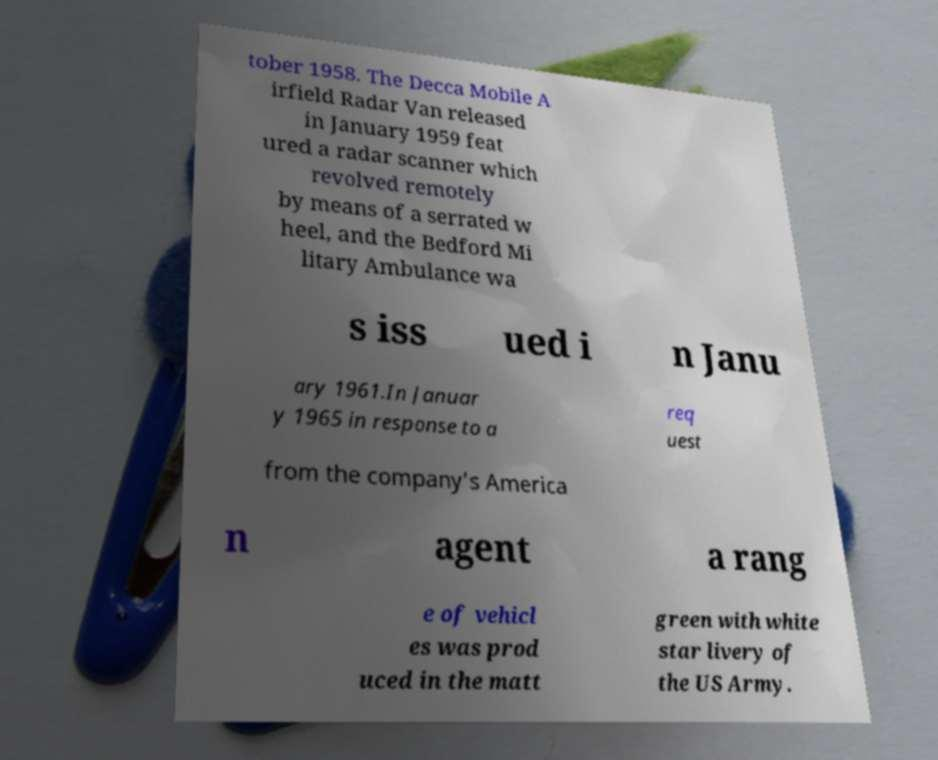Can you read and provide the text displayed in the image?This photo seems to have some interesting text. Can you extract and type it out for me? tober 1958. The Decca Mobile A irfield Radar Van released in January 1959 feat ured a radar scanner which revolved remotely by means of a serrated w heel, and the Bedford Mi litary Ambulance wa s iss ued i n Janu ary 1961.In Januar y 1965 in response to a req uest from the company's America n agent a rang e of vehicl es was prod uced in the matt green with white star livery of the US Army. 